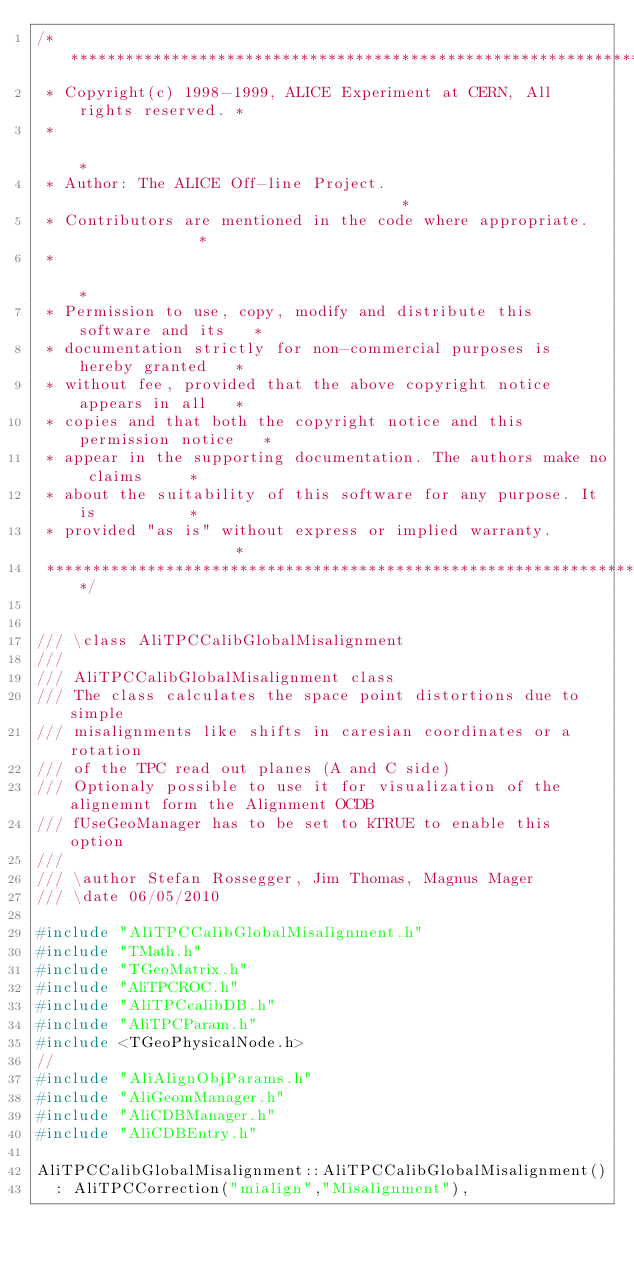Convert code to text. <code><loc_0><loc_0><loc_500><loc_500><_C++_>/**************************************************************************
 * Copyright(c) 1998-1999, ALICE Experiment at CERN, All rights reserved. *
 *                                                                        *
 * Author: The ALICE Off-line Project.                                    *
 * Contributors are mentioned in the code where appropriate.              *
 *                                                                        *
 * Permission to use, copy, modify and distribute this software and its   *
 * documentation strictly for non-commercial purposes is hereby granted   *
 * without fee, provided that the above copyright notice appears in all   *
 * copies and that both the copyright notice and this permission notice   *
 * appear in the supporting documentation. The authors make no claims     *
 * about the suitability of this software for any purpose. It is          *
 * provided "as is" without express or implied warranty.                  *
 **************************************************************************/


/// \class AliTPCCalibGlobalMisalignment
///
/// AliTPCCalibGlobalMisalignment class
/// The class calculates the space point distortions due to simple
/// misalignments like shifts in caresian coordinates or a rotation
/// of the TPC read out planes (A and C side)
/// Optionaly possible to use it for visualization of the alignemnt form the Alignment OCDB
/// fUseGeoManager has to be set to kTRUE to enable this option
///
/// \author Stefan Rossegger, Jim Thomas, Magnus Mager
/// \date 06/05/2010

#include "AliTPCCalibGlobalMisalignment.h"
#include "TMath.h"
#include "TGeoMatrix.h"
#include "AliTPCROC.h"
#include "AliTPCcalibDB.h"
#include "AliTPCParam.h"
#include <TGeoPhysicalNode.h>
//
#include "AliAlignObjParams.h"
#include "AliGeomManager.h"
#include "AliCDBManager.h"
#include "AliCDBEntry.h"

AliTPCCalibGlobalMisalignment::AliTPCCalibGlobalMisalignment()
  : AliTPCCorrection("mialign","Misalignment"),</code> 